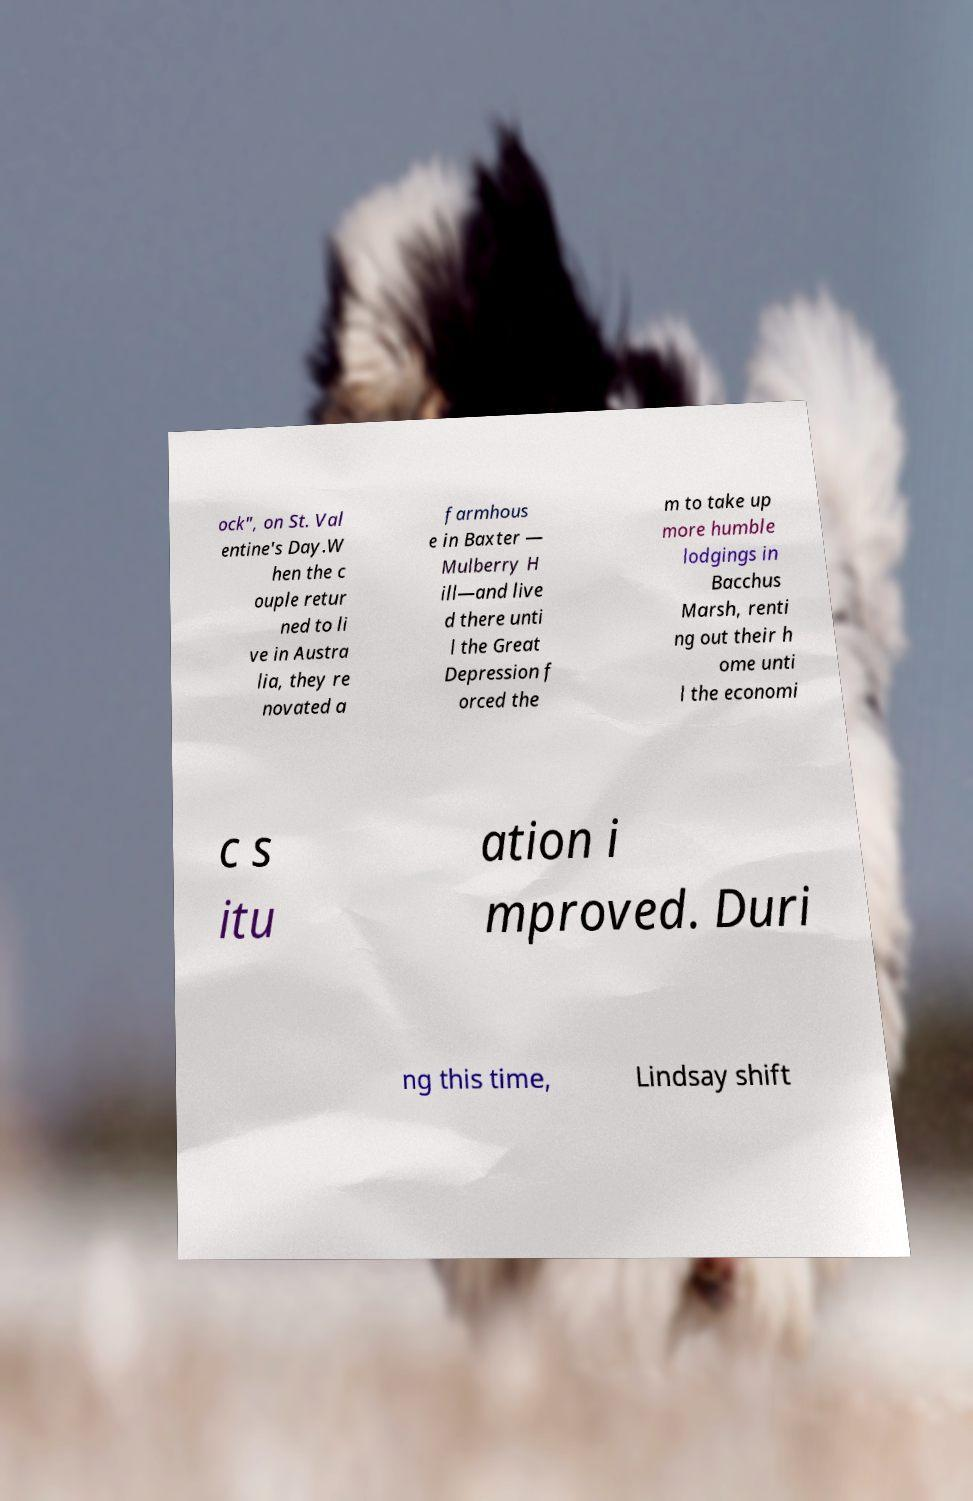Please read and relay the text visible in this image. What does it say? ock", on St. Val entine's Day.W hen the c ouple retur ned to li ve in Austra lia, they re novated a farmhous e in Baxter — Mulberry H ill—and live d there unti l the Great Depression f orced the m to take up more humble lodgings in Bacchus Marsh, renti ng out their h ome unti l the economi c s itu ation i mproved. Duri ng this time, Lindsay shift 